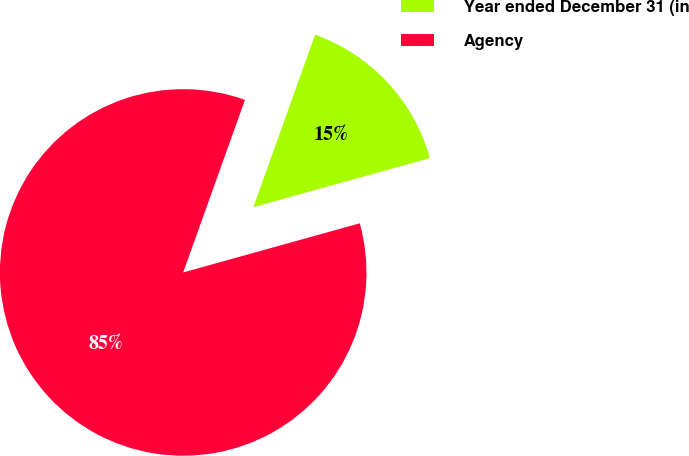<chart> <loc_0><loc_0><loc_500><loc_500><pie_chart><fcel>Year ended December 31 (in<fcel>Agency<nl><fcel>15.21%<fcel>84.79%<nl></chart> 